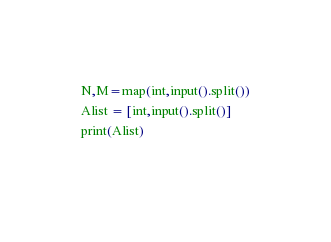<code> <loc_0><loc_0><loc_500><loc_500><_Python_>N,M=map(int,input().split())
Alist = [int,input().split()]
print(Alist)
  
</code> 